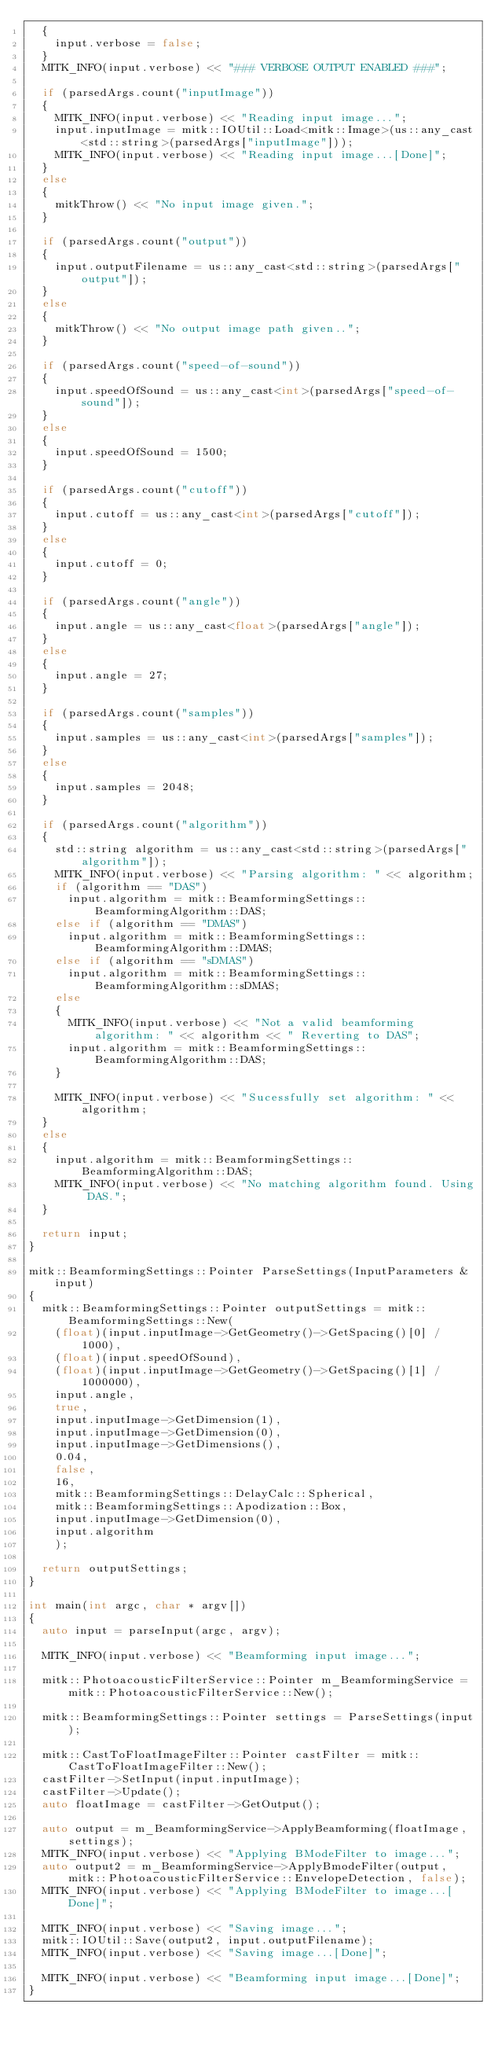Convert code to text. <code><loc_0><loc_0><loc_500><loc_500><_C++_>  {
    input.verbose = false;
  }
  MITK_INFO(input.verbose) << "### VERBOSE OUTPUT ENABLED ###";

  if (parsedArgs.count("inputImage"))
  {
    MITK_INFO(input.verbose) << "Reading input image...";
    input.inputImage = mitk::IOUtil::Load<mitk::Image>(us::any_cast<std::string>(parsedArgs["inputImage"]));
    MITK_INFO(input.verbose) << "Reading input image...[Done]";
  }
  else
  {
    mitkThrow() << "No input image given.";
  }

  if (parsedArgs.count("output"))
  {
    input.outputFilename = us::any_cast<std::string>(parsedArgs["output"]);
  }
  else
  {
    mitkThrow() << "No output image path given..";
  }

  if (parsedArgs.count("speed-of-sound"))
  {
    input.speedOfSound = us::any_cast<int>(parsedArgs["speed-of-sound"]);
  }
  else
  {
    input.speedOfSound = 1500;
  }

  if (parsedArgs.count("cutoff"))
  {
    input.cutoff = us::any_cast<int>(parsedArgs["cutoff"]);
  }
  else
  {
    input.cutoff = 0;
  }

  if (parsedArgs.count("angle"))
  {
    input.angle = us::any_cast<float>(parsedArgs["angle"]);
  }
  else
  {
    input.angle = 27;
  }

  if (parsedArgs.count("samples"))
  {
    input.samples = us::any_cast<int>(parsedArgs["samples"]);
  }
  else
  {
    input.samples = 2048;
  }

  if (parsedArgs.count("algorithm"))
  {
    std::string algorithm = us::any_cast<std::string>(parsedArgs["algorithm"]);
    MITK_INFO(input.verbose) << "Parsing algorithm: " << algorithm;
    if (algorithm == "DAS")
      input.algorithm = mitk::BeamformingSettings::BeamformingAlgorithm::DAS;
    else if (algorithm == "DMAS")
      input.algorithm = mitk::BeamformingSettings::BeamformingAlgorithm::DMAS;
    else if (algorithm == "sDMAS")
      input.algorithm = mitk::BeamformingSettings::BeamformingAlgorithm::sDMAS;
    else
    {
      MITK_INFO(input.verbose) << "Not a valid beamforming algorithm: " << algorithm << " Reverting to DAS";
      input.algorithm = mitk::BeamformingSettings::BeamformingAlgorithm::DAS;
    }

    MITK_INFO(input.verbose) << "Sucessfully set algorithm: " << algorithm;
  }
  else
  {
    input.algorithm = mitk::BeamformingSettings::BeamformingAlgorithm::DAS;
    MITK_INFO(input.verbose) << "No matching algorithm found. Using DAS.";
  }

  return input;
}

mitk::BeamformingSettings::Pointer ParseSettings(InputParameters &input)
{
  mitk::BeamformingSettings::Pointer outputSettings = mitk::BeamformingSettings::New(
    (float)(input.inputImage->GetGeometry()->GetSpacing()[0] / 1000),
    (float)(input.speedOfSound),
    (float)(input.inputImage->GetGeometry()->GetSpacing()[1] / 1000000),
    input.angle,
    true,
    input.inputImage->GetDimension(1),
    input.inputImage->GetDimension(0),
    input.inputImage->GetDimensions(),
    0.04,
    false,
    16,
    mitk::BeamformingSettings::DelayCalc::Spherical,
    mitk::BeamformingSettings::Apodization::Box,
    input.inputImage->GetDimension(0),
    input.algorithm
    );

  return outputSettings;
}

int main(int argc, char * argv[])
{
  auto input = parseInput(argc, argv);

  MITK_INFO(input.verbose) << "Beamforming input image...";

  mitk::PhotoacousticFilterService::Pointer m_BeamformingService = mitk::PhotoacousticFilterService::New();

  mitk::BeamformingSettings::Pointer settings = ParseSettings(input);

  mitk::CastToFloatImageFilter::Pointer castFilter = mitk::CastToFloatImageFilter::New();
  castFilter->SetInput(input.inputImage);
  castFilter->Update();
  auto floatImage = castFilter->GetOutput();

  auto output = m_BeamformingService->ApplyBeamforming(floatImage, settings);
  MITK_INFO(input.verbose) << "Applying BModeFilter to image...";
  auto output2 = m_BeamformingService->ApplyBmodeFilter(output, mitk::PhotoacousticFilterService::EnvelopeDetection, false);
  MITK_INFO(input.verbose) << "Applying BModeFilter to image...[Done]";

  MITK_INFO(input.verbose) << "Saving image...";
  mitk::IOUtil::Save(output2, input.outputFilename);
  MITK_INFO(input.verbose) << "Saving image...[Done]";

  MITK_INFO(input.verbose) << "Beamforming input image...[Done]";
}
</code> 